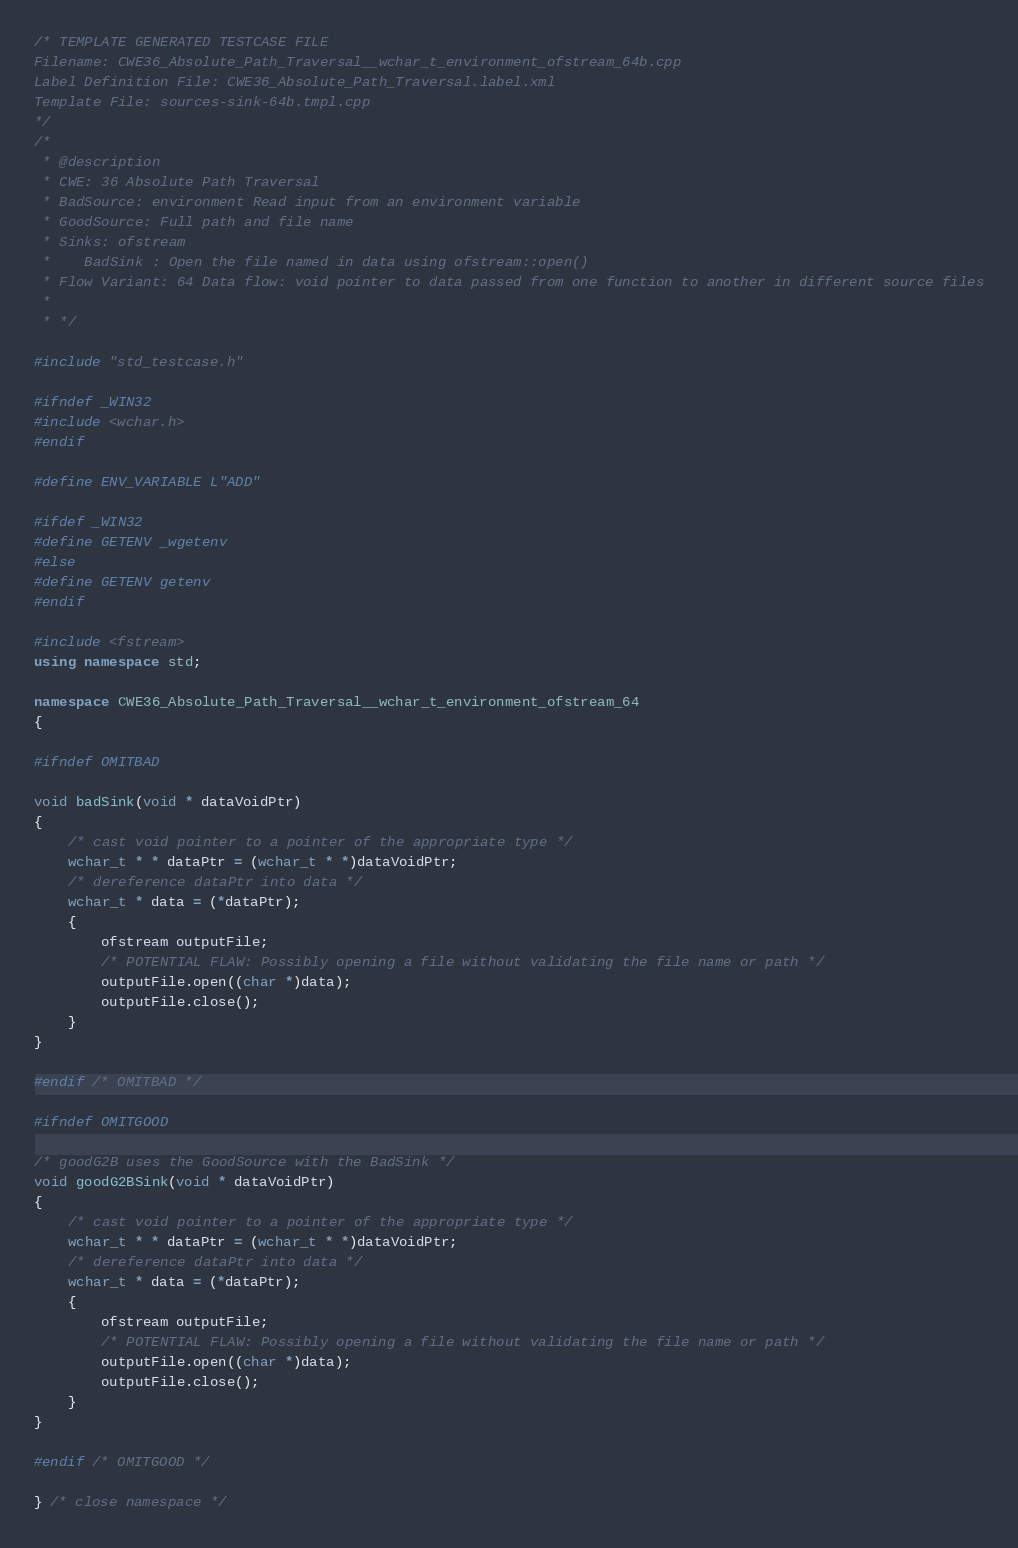<code> <loc_0><loc_0><loc_500><loc_500><_C++_>/* TEMPLATE GENERATED TESTCASE FILE
Filename: CWE36_Absolute_Path_Traversal__wchar_t_environment_ofstream_64b.cpp
Label Definition File: CWE36_Absolute_Path_Traversal.label.xml
Template File: sources-sink-64b.tmpl.cpp
*/
/*
 * @description
 * CWE: 36 Absolute Path Traversal
 * BadSource: environment Read input from an environment variable
 * GoodSource: Full path and file name
 * Sinks: ofstream
 *    BadSink : Open the file named in data using ofstream::open()
 * Flow Variant: 64 Data flow: void pointer to data passed from one function to another in different source files
 *
 * */

#include "std_testcase.h"

#ifndef _WIN32
#include <wchar.h>
#endif

#define ENV_VARIABLE L"ADD"

#ifdef _WIN32
#define GETENV _wgetenv
#else
#define GETENV getenv
#endif

#include <fstream>
using namespace std;

namespace CWE36_Absolute_Path_Traversal__wchar_t_environment_ofstream_64
{

#ifndef OMITBAD

void badSink(void * dataVoidPtr)
{
    /* cast void pointer to a pointer of the appropriate type */
    wchar_t * * dataPtr = (wchar_t * *)dataVoidPtr;
    /* dereference dataPtr into data */
    wchar_t * data = (*dataPtr);
    {
        ofstream outputFile;
        /* POTENTIAL FLAW: Possibly opening a file without validating the file name or path */
        outputFile.open((char *)data);
        outputFile.close();
    }
}

#endif /* OMITBAD */

#ifndef OMITGOOD

/* goodG2B uses the GoodSource with the BadSink */
void goodG2BSink(void * dataVoidPtr)
{
    /* cast void pointer to a pointer of the appropriate type */
    wchar_t * * dataPtr = (wchar_t * *)dataVoidPtr;
    /* dereference dataPtr into data */
    wchar_t * data = (*dataPtr);
    {
        ofstream outputFile;
        /* POTENTIAL FLAW: Possibly opening a file without validating the file name or path */
        outputFile.open((char *)data);
        outputFile.close();
    }
}

#endif /* OMITGOOD */

} /* close namespace */
</code> 